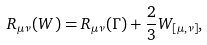Convert formula to latex. <formula><loc_0><loc_0><loc_500><loc_500>R _ { \mu \nu } ( W ) = R _ { \mu \nu } ( \Gamma ) + \frac { 2 } { 3 } W _ { [ \mu , \nu ] } ,</formula> 